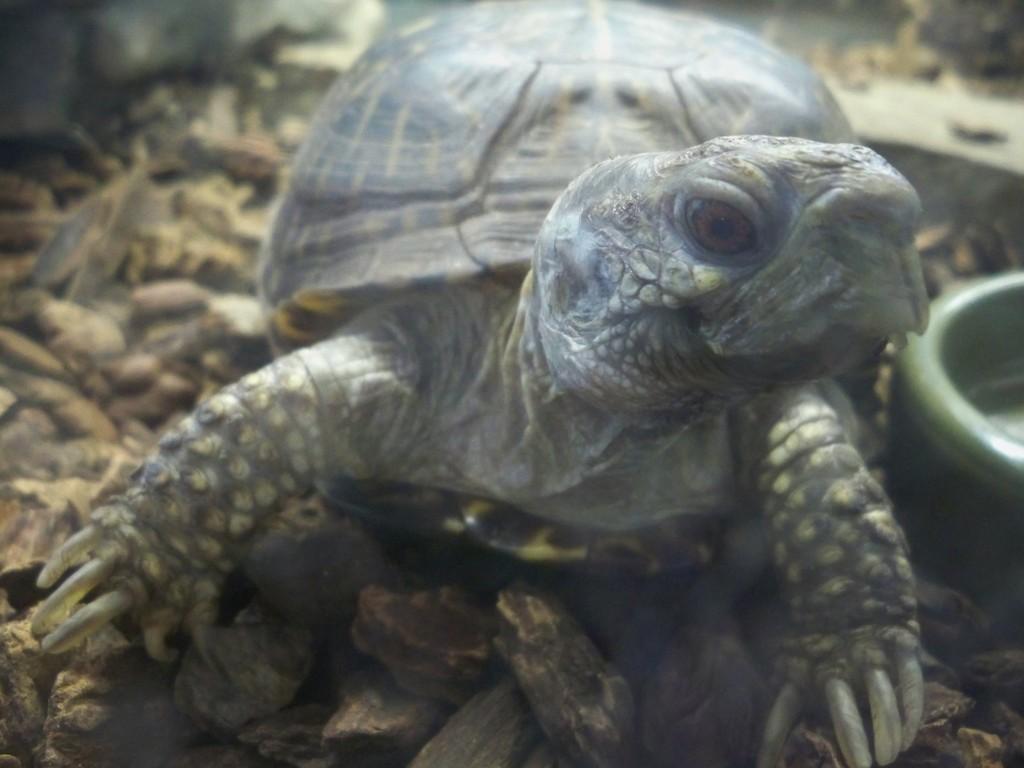Please provide a concise description of this image. This picture contains a turtle. Beside that, we see a green color thing which looks like a bowl. In the background, we see small stones. 